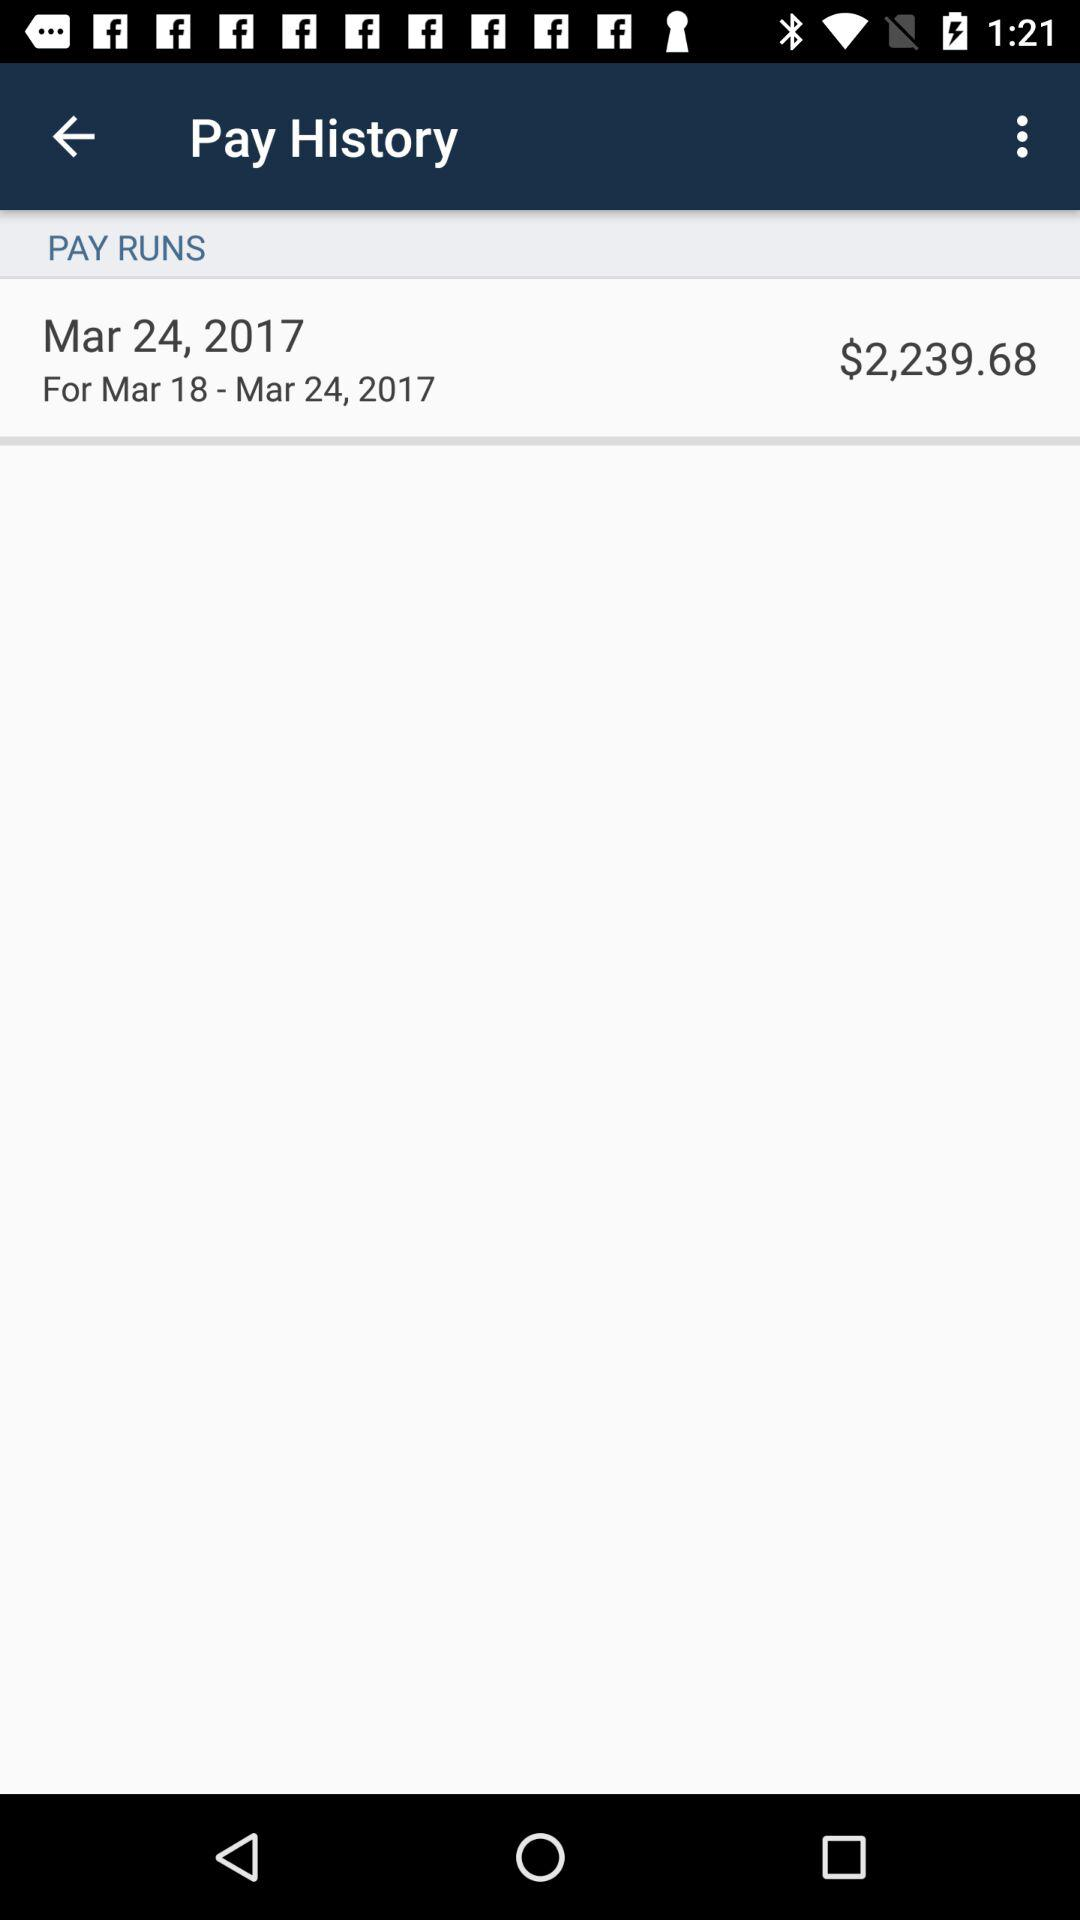What is the total amount? The total amount is $2,239.68. 